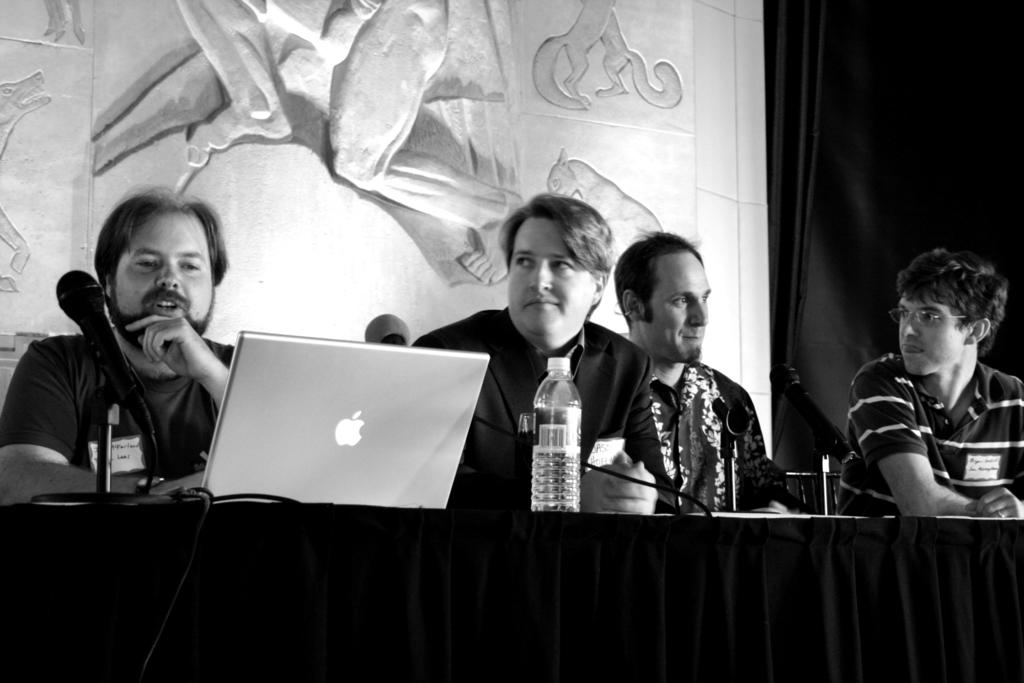How many people are in the image? There is a group of people in the image. What are the people doing in the image? The people are sitting on chairs. What is in front of the chairs? There is a table in front of the chairs. What objects can be seen on the table? There are microphones, a bottle, and a laptop on the table. What is behind the people in the image? There is a wall behind the people. What is on the wall? The wall has some art on it. What type of rain is falling on the people in the image? There is no rain present in the image; it is an indoor setting with a group of people sitting on chairs. 